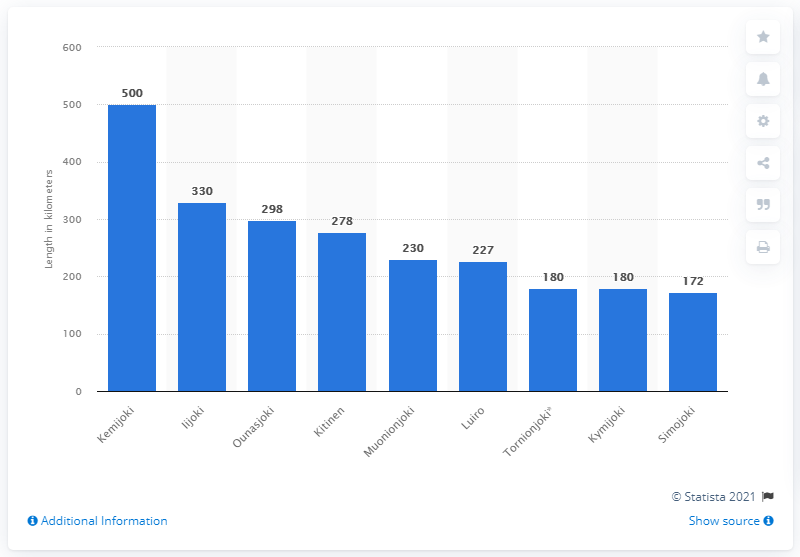Point out several critical features in this image. The Kemijoki is the longest river in Finland. 